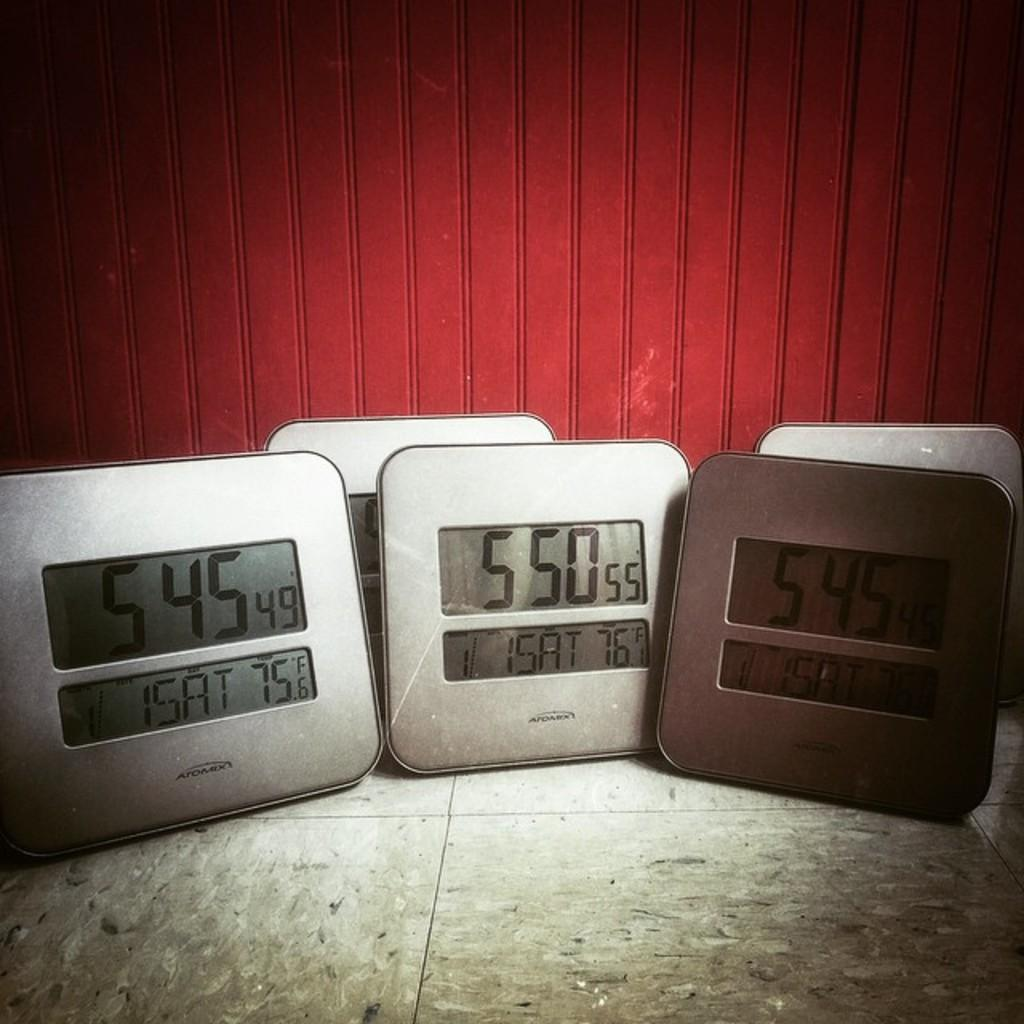<image>
Write a terse but informative summary of the picture. Multiple clocks in front of a red wall showing the time at 5:45 